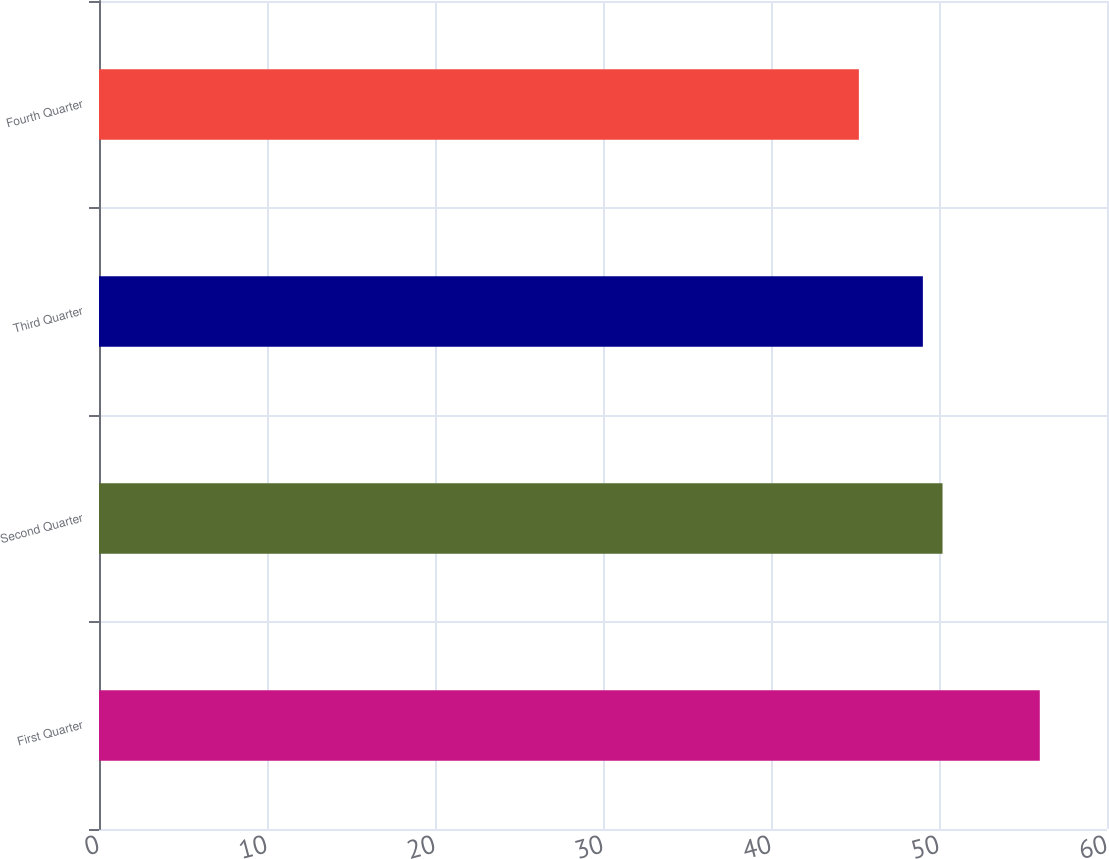Convert chart to OTSL. <chart><loc_0><loc_0><loc_500><loc_500><bar_chart><fcel>First Quarter<fcel>Second Quarter<fcel>Third Quarter<fcel>Fourth Quarter<nl><fcel>56<fcel>50.21<fcel>49.04<fcel>45.23<nl></chart> 